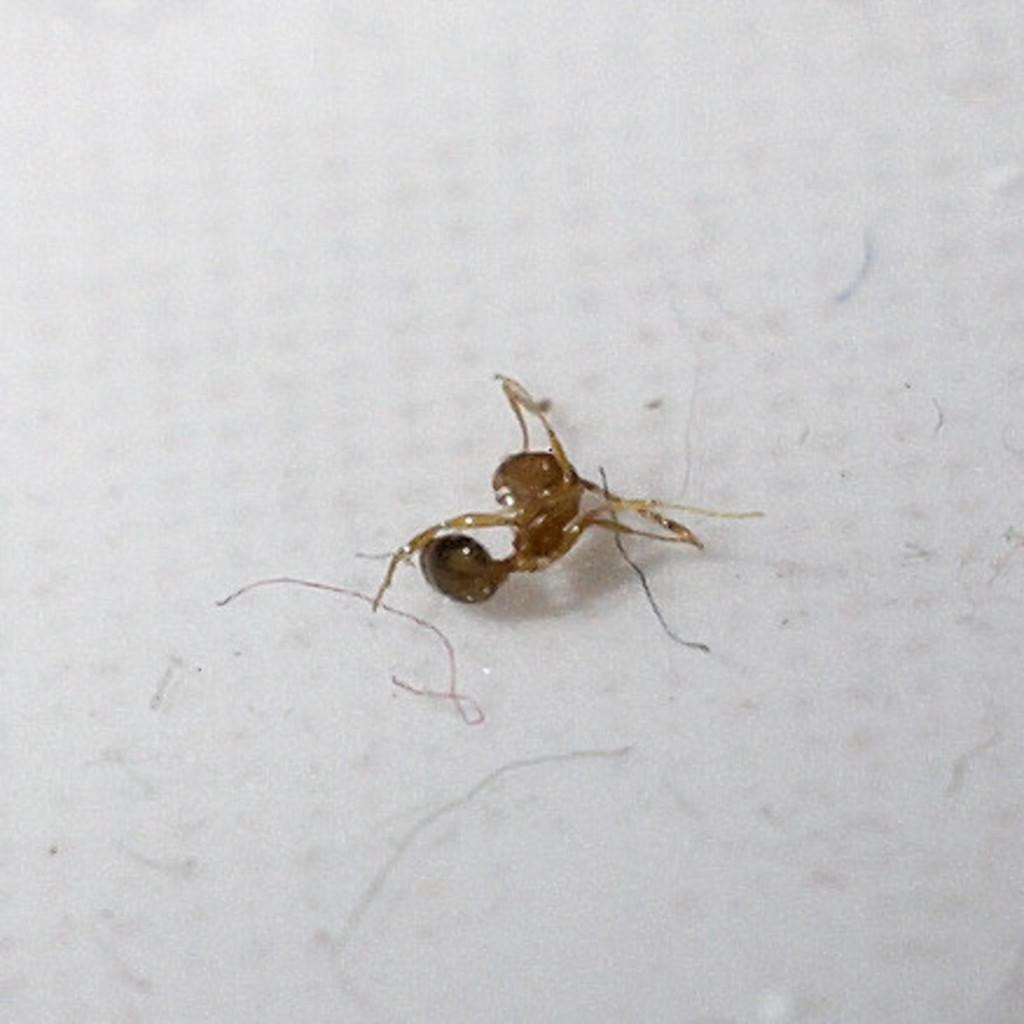What type of creature is present in the image? There is an insect in the image. Can you describe the insect's location in the image? The insect is on a surface in the image. What color is the insect in the image? The insect is white in color. What type of crime is the insect committing in the image? There is no crime being committed in the image; it simply features an insect on a surface. Is the insect wearing a scarf in the image? There is no scarf present in the image, nor is the insect wearing any clothing. 